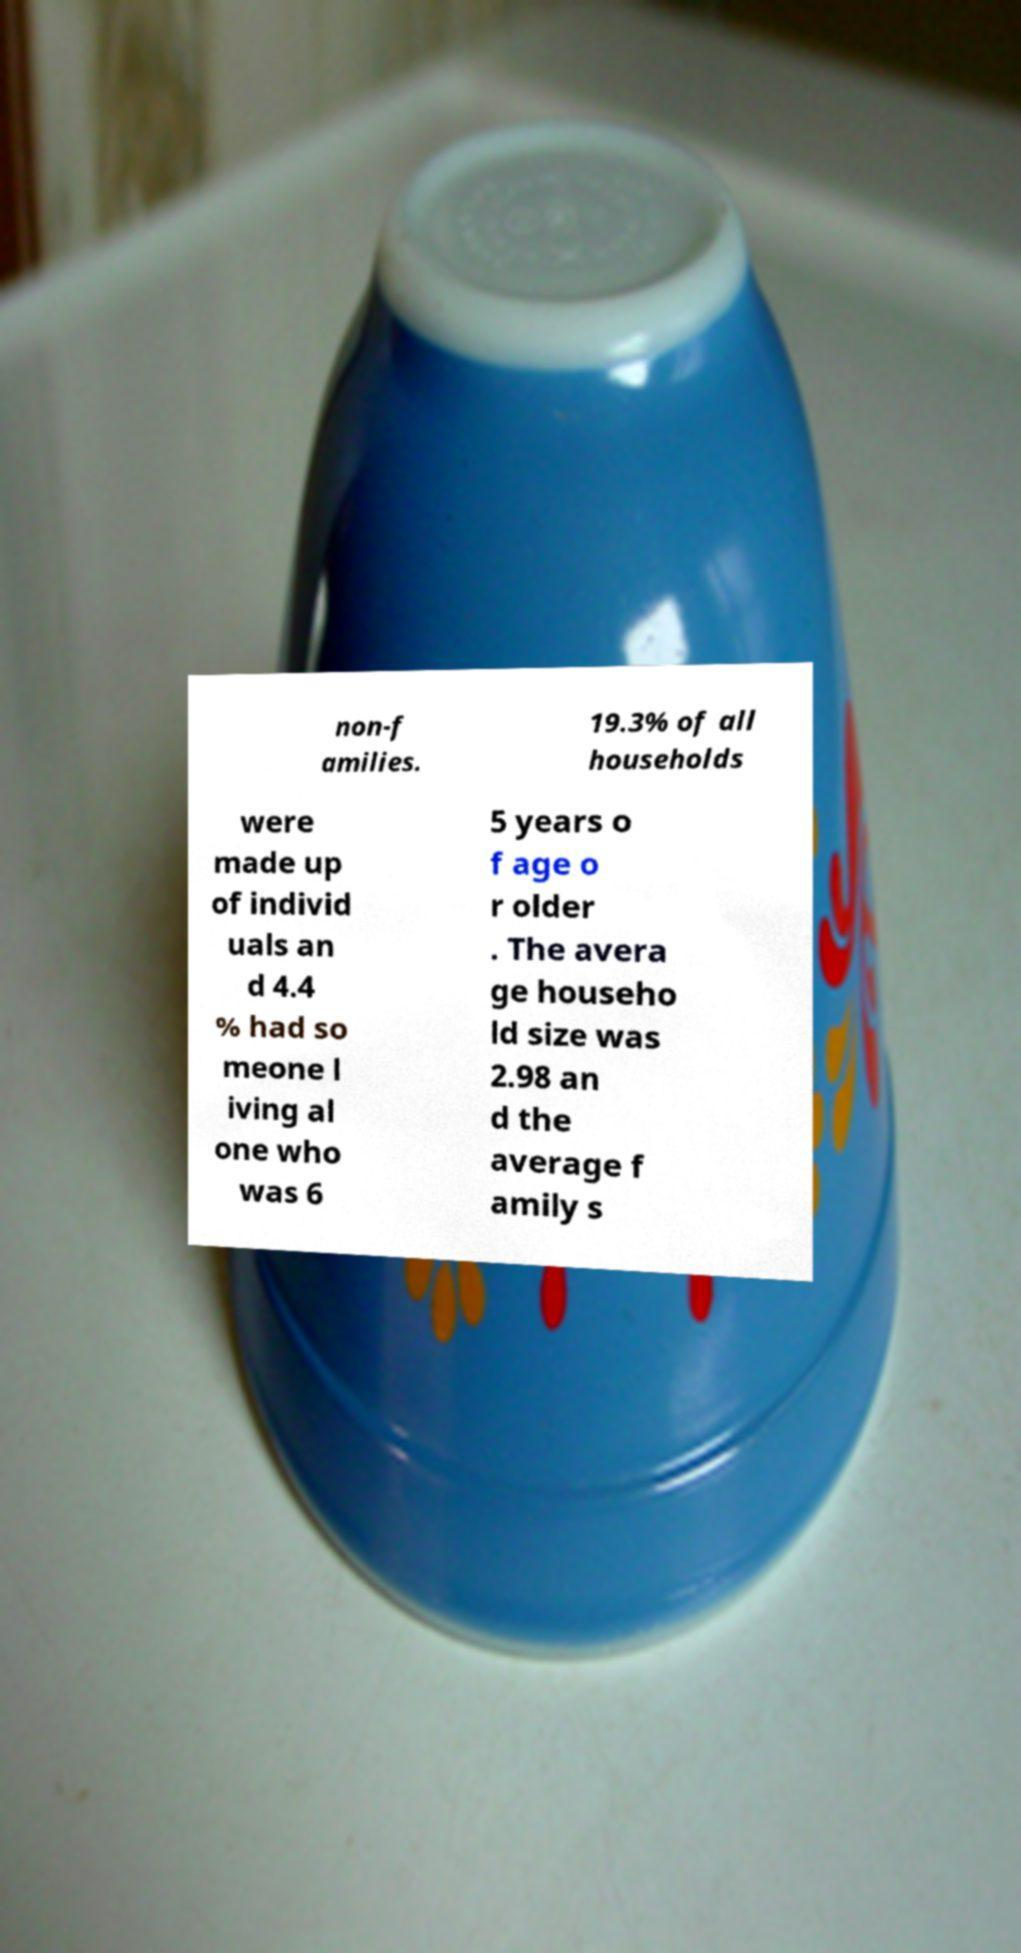What messages or text are displayed in this image? I need them in a readable, typed format. non-f amilies. 19.3% of all households were made up of individ uals an d 4.4 % had so meone l iving al one who was 6 5 years o f age o r older . The avera ge househo ld size was 2.98 an d the average f amily s 